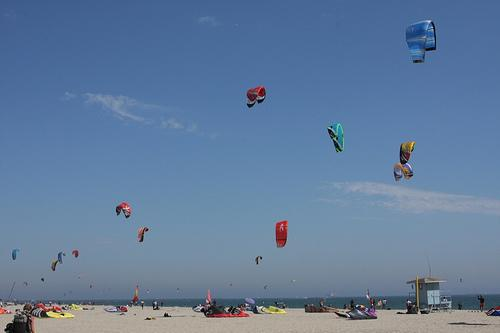What is the building for?

Choices:
A) library
B) church
C) lifeguard
D) hospital lifeguard 